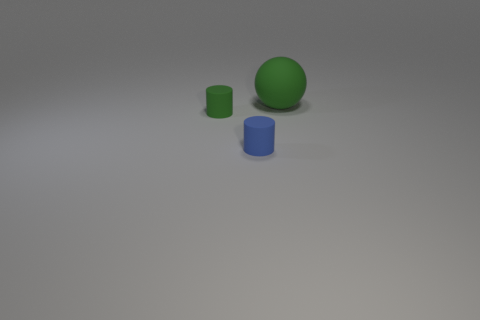Subtract 1 spheres. How many spheres are left? 0 Subtract all red cylinders. Subtract all green cubes. How many cylinders are left? 2 Subtract all purple blocks. How many gray spheres are left? 0 Subtract all small purple matte objects. Subtract all large green matte balls. How many objects are left? 2 Add 1 tiny blue objects. How many tiny blue objects are left? 2 Add 1 yellow matte objects. How many yellow matte objects exist? 1 Add 2 large blue metal balls. How many objects exist? 5 Subtract 0 green blocks. How many objects are left? 3 Subtract all spheres. How many objects are left? 2 